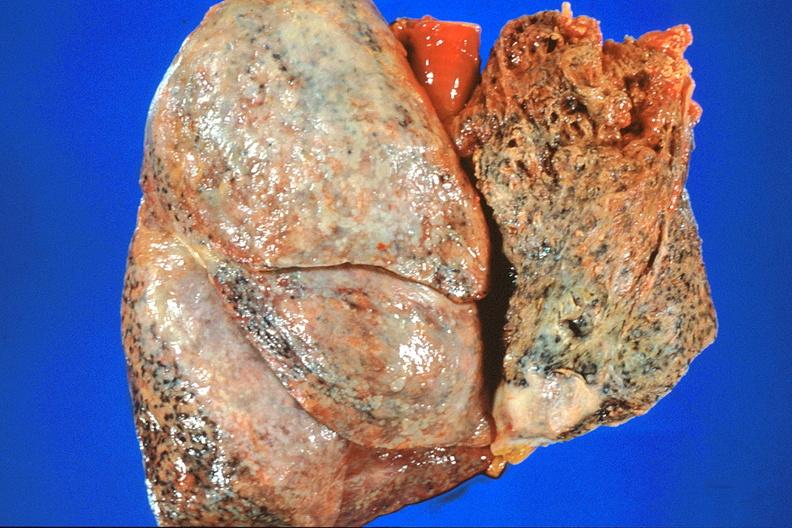what does this image show?
Answer the question using a single word or phrase. Lung 